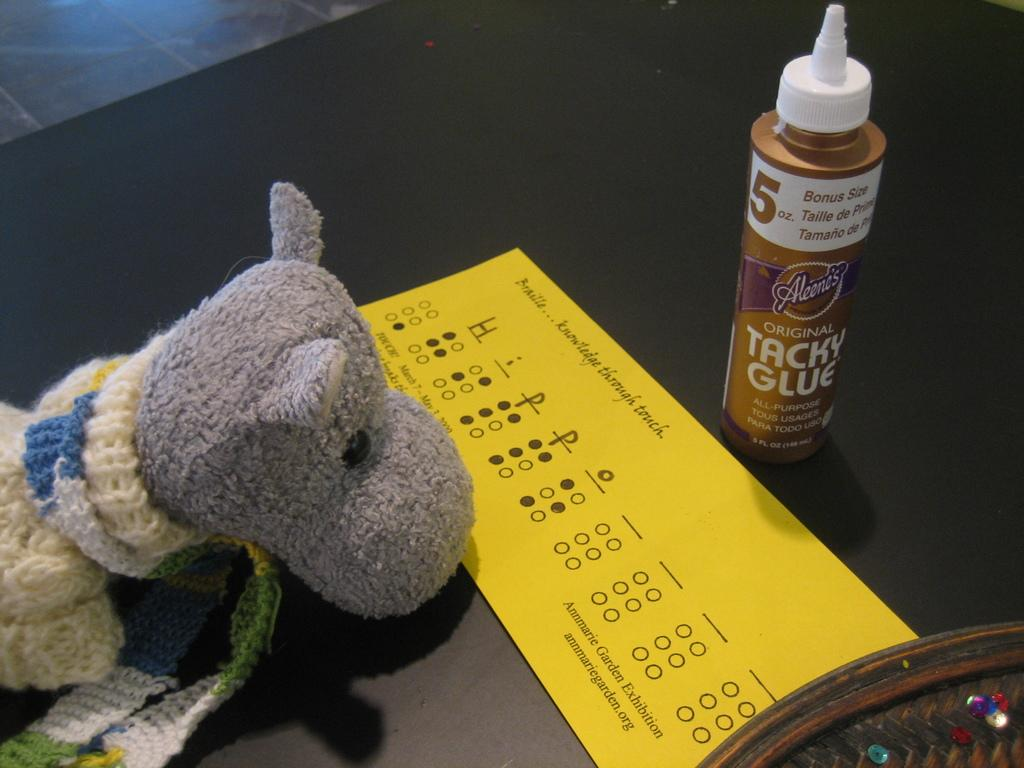<image>
Describe the image concisely. The yellow braille practice card is in between a stuffed hippo and a bottle of Tacky glue. 